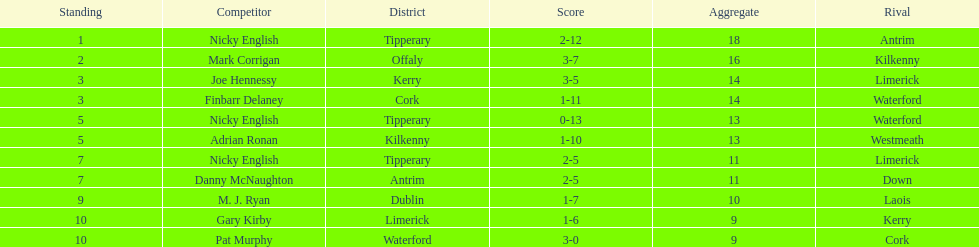What is the first name on the list? Nicky English. Can you parse all the data within this table? {'header': ['Standing', 'Competitor', 'District', 'Score', 'Aggregate', 'Rival'], 'rows': [['1', 'Nicky English', 'Tipperary', '2-12', '18', 'Antrim'], ['2', 'Mark Corrigan', 'Offaly', '3-7', '16', 'Kilkenny'], ['3', 'Joe Hennessy', 'Kerry', '3-5', '14', 'Limerick'], ['3', 'Finbarr Delaney', 'Cork', '1-11', '14', 'Waterford'], ['5', 'Nicky English', 'Tipperary', '0-13', '13', 'Waterford'], ['5', 'Adrian Ronan', 'Kilkenny', '1-10', '13', 'Westmeath'], ['7', 'Nicky English', 'Tipperary', '2-5', '11', 'Limerick'], ['7', 'Danny McNaughton', 'Antrim', '2-5', '11', 'Down'], ['9', 'M. J. Ryan', 'Dublin', '1-7', '10', 'Laois'], ['10', 'Gary Kirby', 'Limerick', '1-6', '9', 'Kerry'], ['10', 'Pat Murphy', 'Waterford', '3-0', '9', 'Cork']]} 